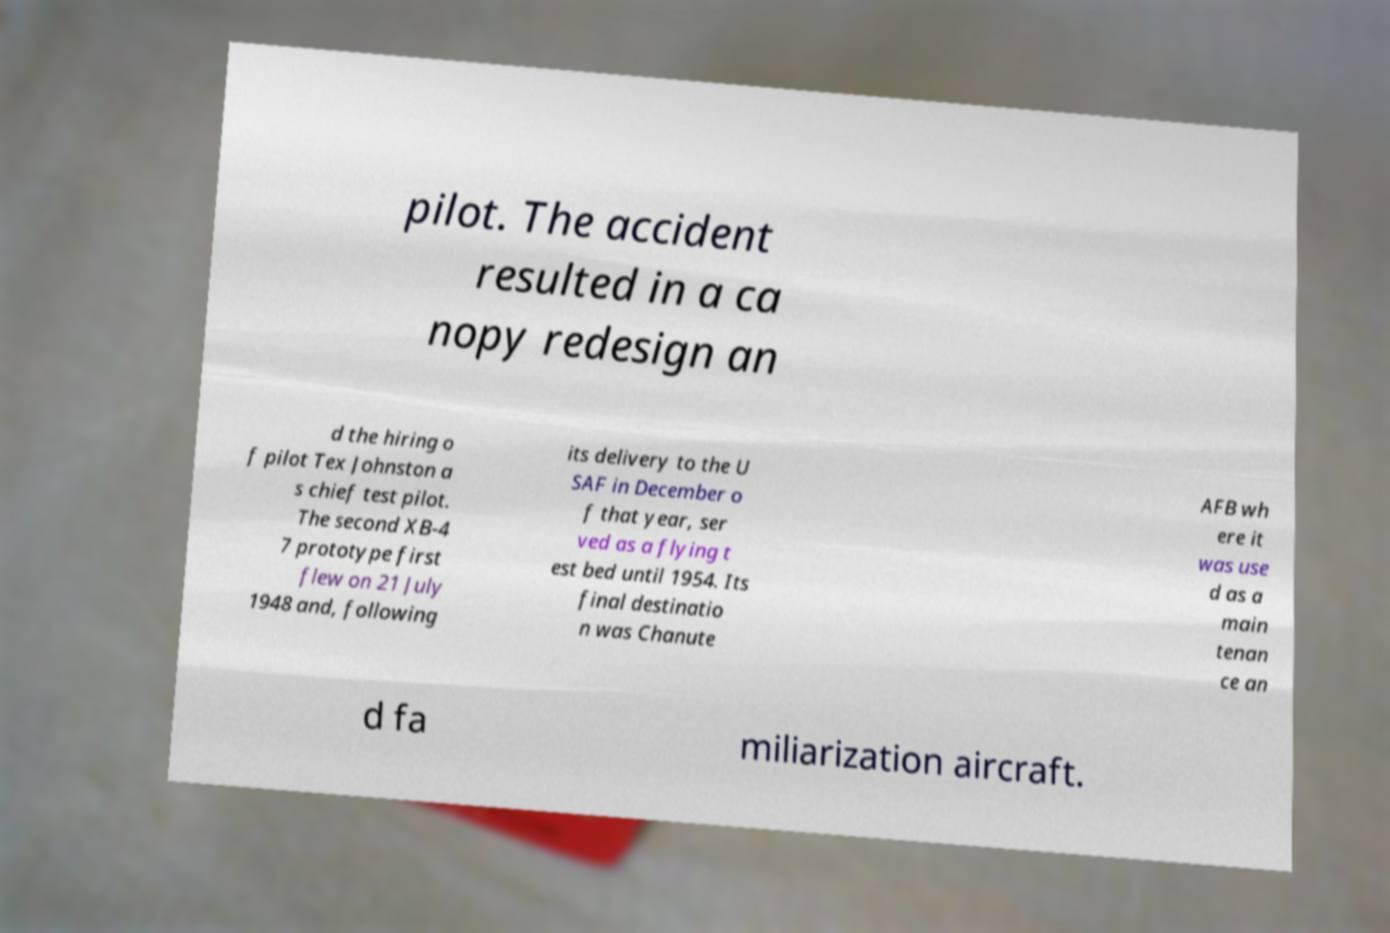Can you read and provide the text displayed in the image?This photo seems to have some interesting text. Can you extract and type it out for me? pilot. The accident resulted in a ca nopy redesign an d the hiring o f pilot Tex Johnston a s chief test pilot. The second XB-4 7 prototype first flew on 21 July 1948 and, following its delivery to the U SAF in December o f that year, ser ved as a flying t est bed until 1954. Its final destinatio n was Chanute AFB wh ere it was use d as a main tenan ce an d fa miliarization aircraft. 